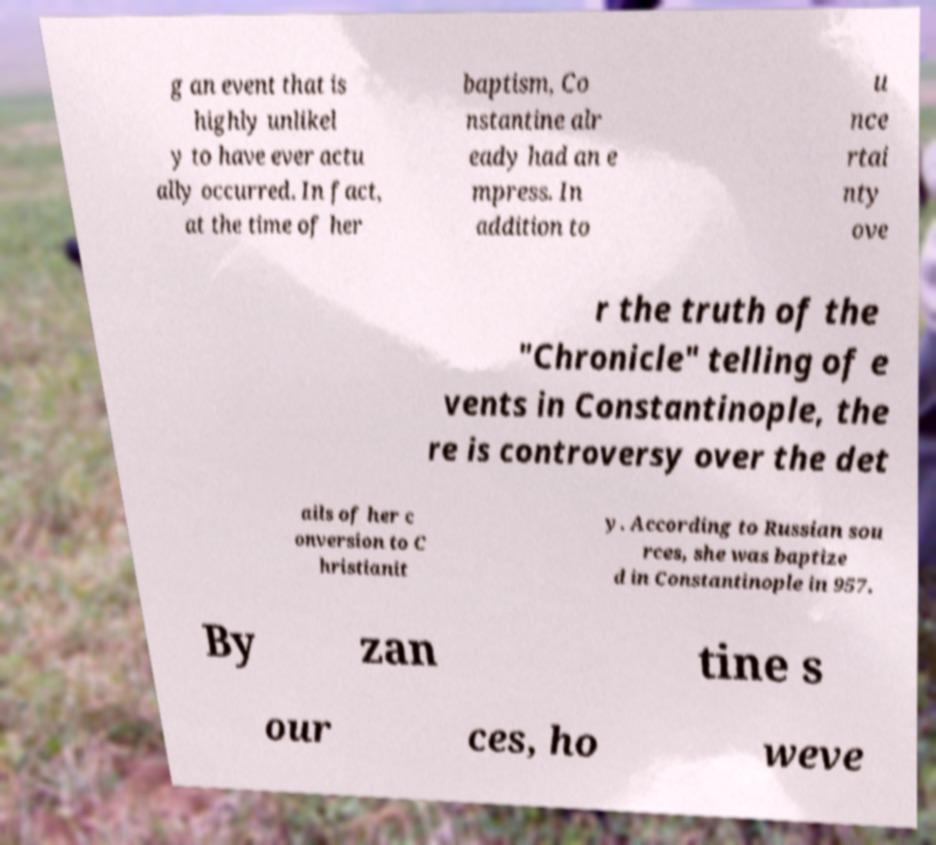There's text embedded in this image that I need extracted. Can you transcribe it verbatim? g an event that is highly unlikel y to have ever actu ally occurred. In fact, at the time of her baptism, Co nstantine alr eady had an e mpress. In addition to u nce rtai nty ove r the truth of the "Chronicle" telling of e vents in Constantinople, the re is controversy over the det ails of her c onversion to C hristianit y. According to Russian sou rces, she was baptize d in Constantinople in 957. By zan tine s our ces, ho weve 